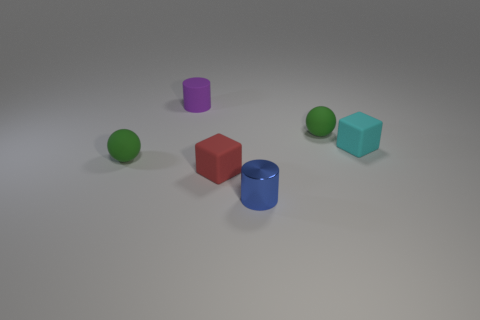Add 3 tiny brown matte spheres. How many objects exist? 9 Add 1 red cylinders. How many red cylinders exist? 1 Subtract 0 gray spheres. How many objects are left? 6 Subtract all red rubber objects. Subtract all big cyan matte things. How many objects are left? 5 Add 1 tiny metal objects. How many tiny metal objects are left? 2 